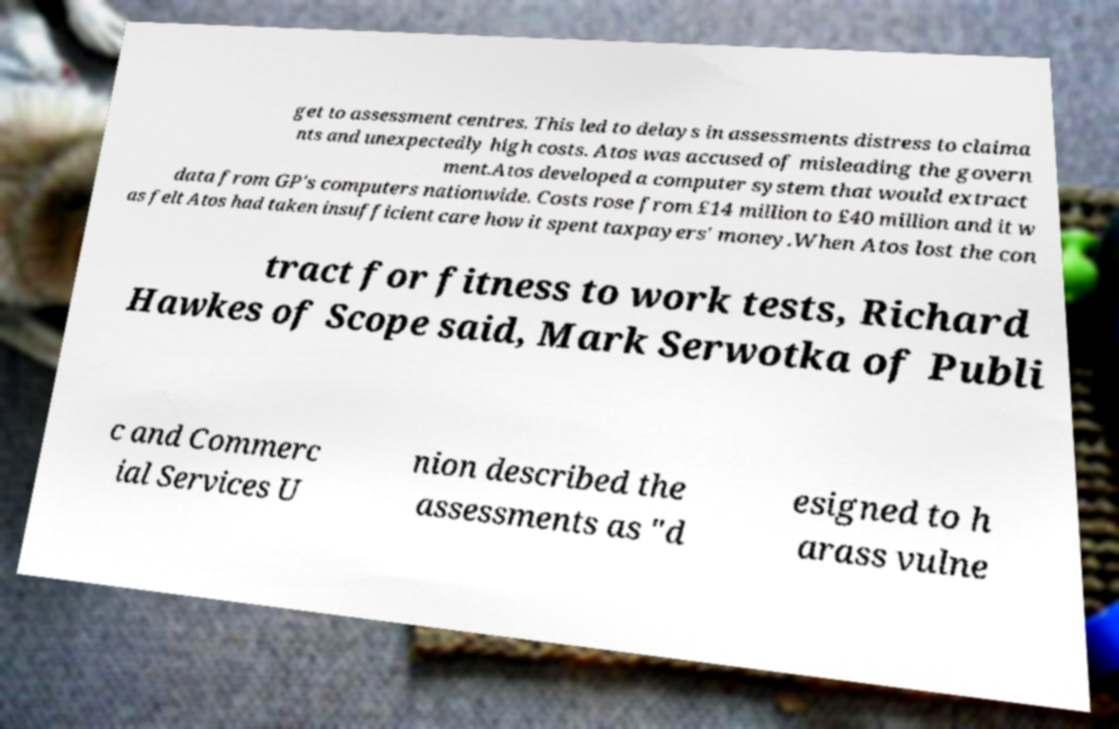Please read and relay the text visible in this image. What does it say? get to assessment centres. This led to delays in assessments distress to claima nts and unexpectedly high costs. Atos was accused of misleading the govern ment.Atos developed a computer system that would extract data from GP's computers nationwide. Costs rose from £14 million to £40 million and it w as felt Atos had taken insufficient care how it spent taxpayers' money.When Atos lost the con tract for fitness to work tests, Richard Hawkes of Scope said, Mark Serwotka of Publi c and Commerc ial Services U nion described the assessments as "d esigned to h arass vulne 